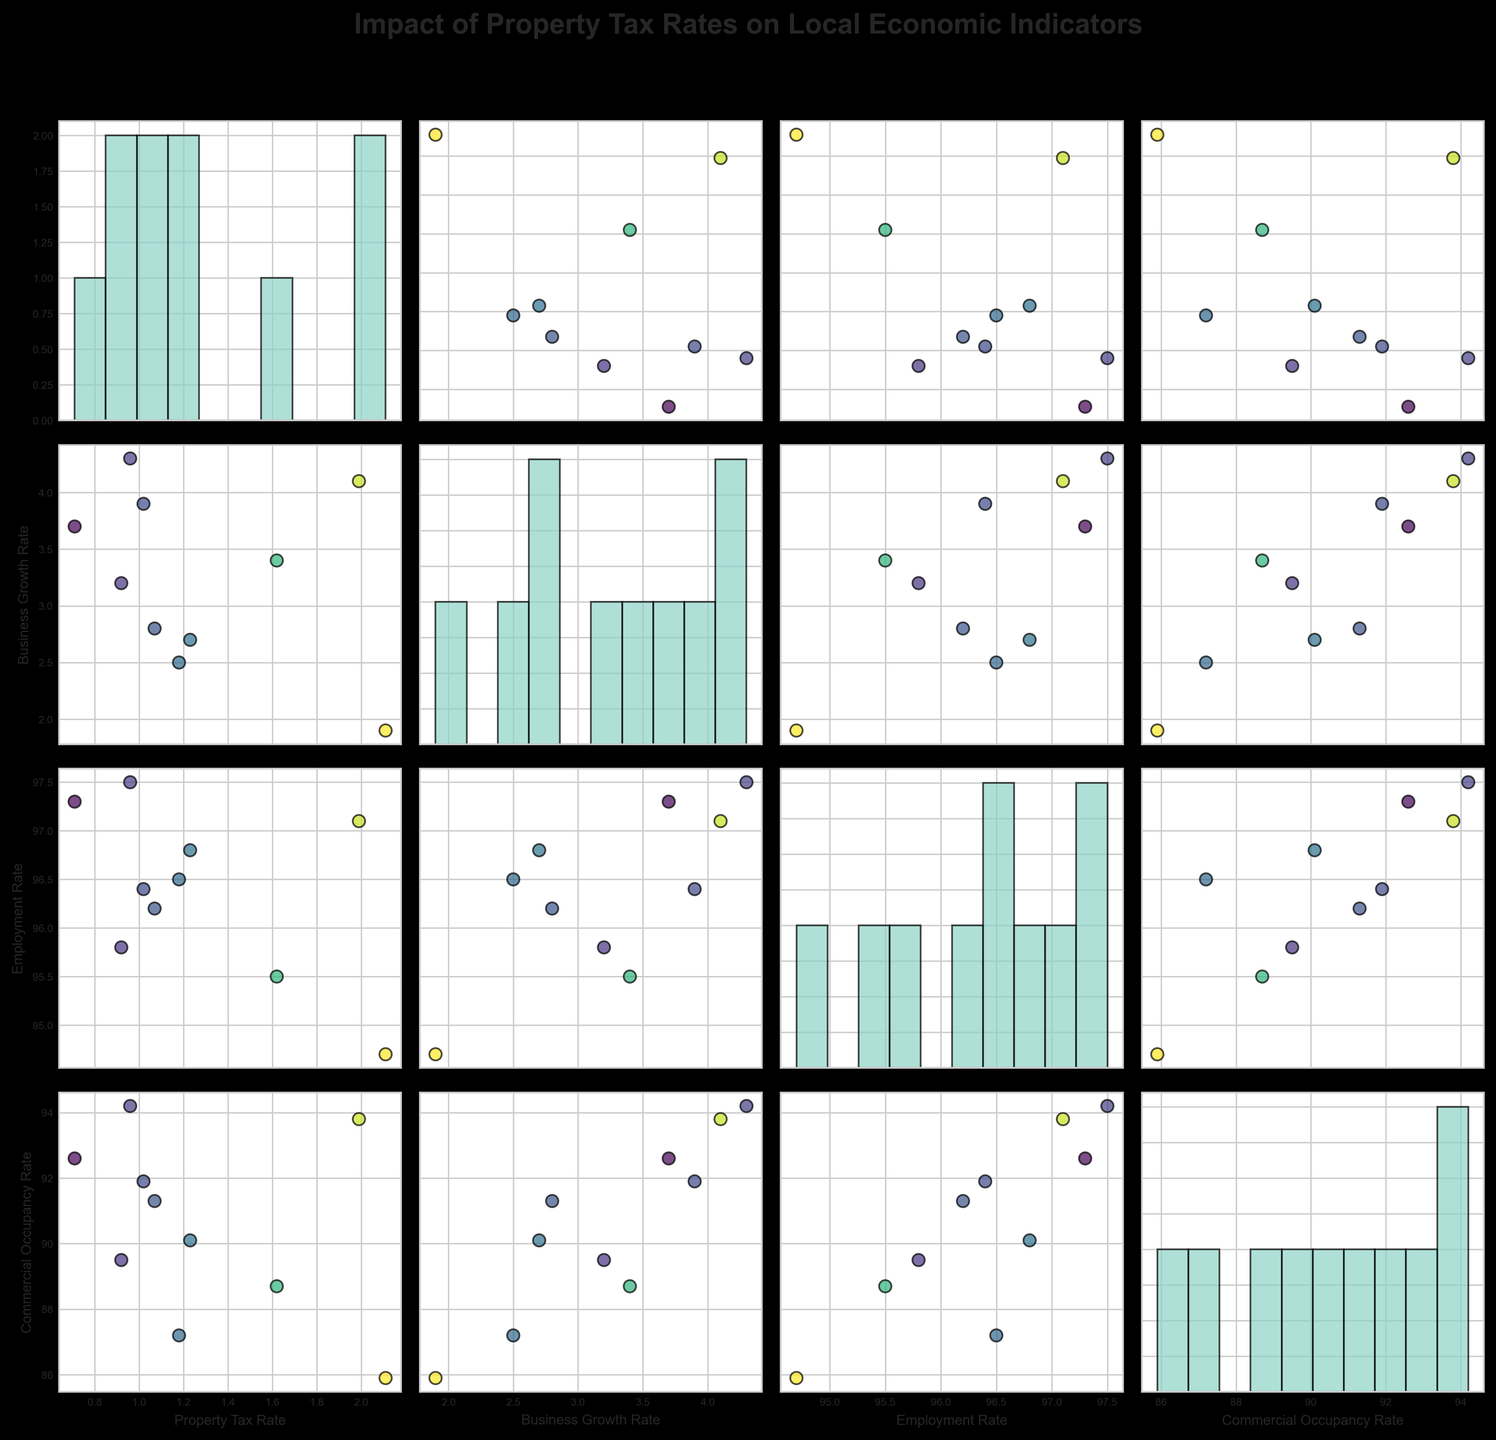What is the title of the figure? The title is generally located at the top of the figure, and for this plot, it indicates the main subject being visualized, which is provided in the plotting code.
Answer: Impact of Property Tax Rates on Local Economic Indicators What variables are shown in the scatterplot matrix? The variables shown are mentioned in the code and can be seen as the labels along the axes in the figure and are Property Tax Rate, Business Growth Rate, Employment Rate, and Commercial Occupancy Rate.
Answer: Property Tax Rate, Business Growth Rate, Employment Rate, Commercial Occupancy Rate How many cities are represented in this figure? Each data point in the scatterplot represents a city, and there are 10 cities mentioned in the provided data.
Answer: 10 Which city has the highest property tax rate? By looking at the axis labels and identifying the highest value data point on the Property Tax Rate axis, we can see that Chicago has the highest value of 2.11.
Answer: Chicago Is there a noticeable trend between Property Tax Rate and Business Growth Rate in this figure? Scanning the scatter plot where Property Tax Rate is on the y-axis and Business Growth Rate is on the x-axis, we focus on the overall direction of data points whether they are increasing, decreasing, or showing no trend. There seems to be a weak trend indicating that lower property tax rates might correspond to higher business growth rates.
Answer: Weak decreasing trend Which city shows the highest commercial occupancy rate and what is its property tax rate? Checking the highest value in the Commercial Occupancy Rate axis and locating the corresponding data point in the scatter matrix gives the city and its respective property tax rate shown in the scatter plot. The highest is for Nashville with a property tax rate of 0.96.
Answer: Nashville, 0.96 Is there a clear relationship between Employment Rate and Commercial Occupancy Rate? By examining the scatterplot with Employment Rate on one axis and Commercial Occupancy Rate on the other, we observe if the data points follow a particular pattern. It appears that higher employment rates are associated with higher commercial occupancy rates.
Answer: Positive relationship What is the average business growth rate in cities with a property tax rate below 1.0? Identify the points with property tax rates <1.0 and calculate the average of their Business Growth Rate values. Data points: Seattle (3.2), Denver (3.7), Nashville (4.3). The average is (3.2 + 3.7 + 4.3) / 3.
Answer: 3.73 Out of the cities with property tax rates above 1.5, which one has the highest business growth rate? Focusing on cities with property tax rates > 1.5 and comparing their Business Growth Rates, Miami has the highest growth rate of 3.9.
Answer: Miami What range of employment rates is observed in the cities with the lowest and the highest property tax rates? Identify the employment rates of the cities with the minimum and maximum property tax rates, respectively, Denver (97.3) for the lowest at 0.71 and Chicago (94.7) for the highest at 2.11.
Answer: 94.7 to 97.3 